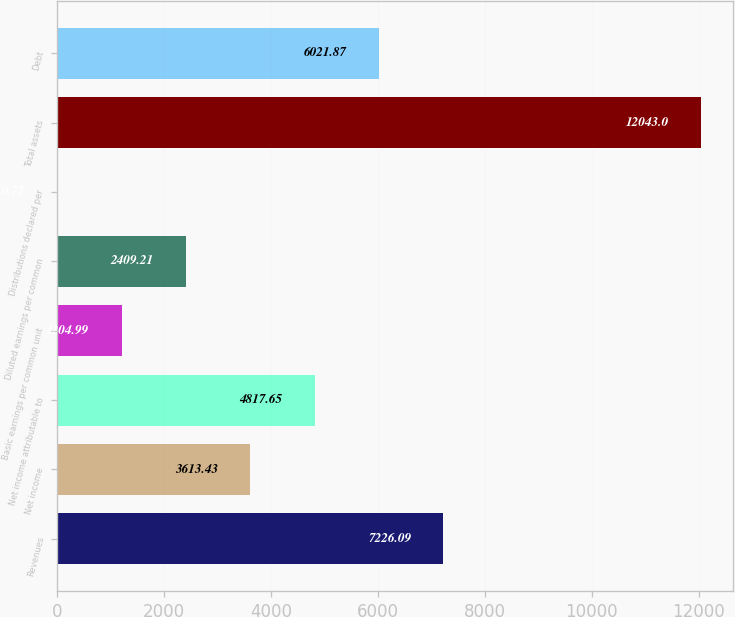Convert chart. <chart><loc_0><loc_0><loc_500><loc_500><bar_chart><fcel>Revenues<fcel>Net income<fcel>Net income attributable to<fcel>Basic earnings per common unit<fcel>Diluted earnings per common<fcel>Distributions declared per<fcel>Total assets<fcel>Debt<nl><fcel>7226.09<fcel>3613.43<fcel>4817.65<fcel>1204.99<fcel>2409.21<fcel>0.77<fcel>12043<fcel>6021.87<nl></chart> 